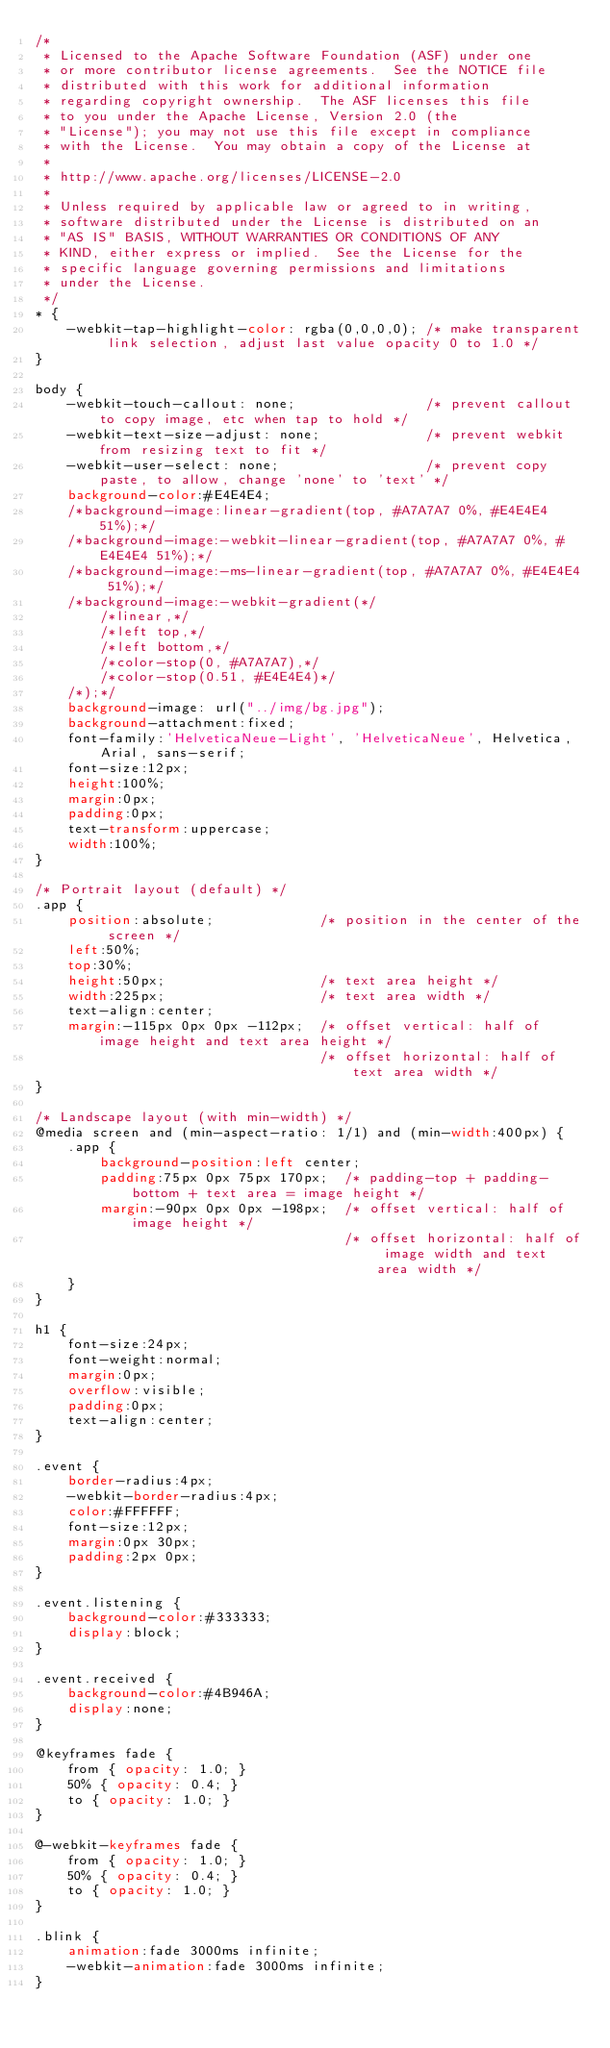Convert code to text. <code><loc_0><loc_0><loc_500><loc_500><_CSS_>/*
 * Licensed to the Apache Software Foundation (ASF) under one
 * or more contributor license agreements.  See the NOTICE file
 * distributed with this work for additional information
 * regarding copyright ownership.  The ASF licenses this file
 * to you under the Apache License, Version 2.0 (the
 * "License"); you may not use this file except in compliance
 * with the License.  You may obtain a copy of the License at
 *
 * http://www.apache.org/licenses/LICENSE-2.0
 *
 * Unless required by applicable law or agreed to in writing,
 * software distributed under the License is distributed on an
 * "AS IS" BASIS, WITHOUT WARRANTIES OR CONDITIONS OF ANY
 * KIND, either express or implied.  See the License for the
 * specific language governing permissions and limitations
 * under the License.
 */
* {
    -webkit-tap-highlight-color: rgba(0,0,0,0); /* make transparent link selection, adjust last value opacity 0 to 1.0 */
}

body {
    -webkit-touch-callout: none;                /* prevent callout to copy image, etc when tap to hold */
    -webkit-text-size-adjust: none;             /* prevent webkit from resizing text to fit */
    -webkit-user-select: none;                  /* prevent copy paste, to allow, change 'none' to 'text' */
    background-color:#E4E4E4;
    /*background-image:linear-gradient(top, #A7A7A7 0%, #E4E4E4 51%);*/
    /*background-image:-webkit-linear-gradient(top, #A7A7A7 0%, #E4E4E4 51%);*/
    /*background-image:-ms-linear-gradient(top, #A7A7A7 0%, #E4E4E4 51%);*/
    /*background-image:-webkit-gradient(*/
        /*linear,*/
        /*left top,*/
        /*left bottom,*/
        /*color-stop(0, #A7A7A7),*/
        /*color-stop(0.51, #E4E4E4)*/
    /*);*/
    background-image: url("../img/bg.jpg");
    background-attachment:fixed;
    font-family:'HelveticaNeue-Light', 'HelveticaNeue', Helvetica, Arial, sans-serif;
    font-size:12px;
    height:100%;
    margin:0px;
    padding:0px;
    text-transform:uppercase;
    width:100%;
}

/* Portrait layout (default) */
.app {
    position:absolute;             /* position in the center of the screen */
    left:50%;
    top:30%;
    height:50px;                   /* text area height */
    width:225px;                   /* text area width */
    text-align:center;
    margin:-115px 0px 0px -112px;  /* offset vertical: half of image height and text area height */
                                   /* offset horizontal: half of text area width */
}

/* Landscape layout (with min-width) */
@media screen and (min-aspect-ratio: 1/1) and (min-width:400px) {
    .app {
        background-position:left center;
        padding:75px 0px 75px 170px;  /* padding-top + padding-bottom + text area = image height */
        margin:-90px 0px 0px -198px;  /* offset vertical: half of image height */
                                      /* offset horizontal: half of image width and text area width */
    }
}

h1 {
    font-size:24px;
    font-weight:normal;
    margin:0px;
    overflow:visible;
    padding:0px;
    text-align:center;
}

.event {
    border-radius:4px;
    -webkit-border-radius:4px;
    color:#FFFFFF;
    font-size:12px;
    margin:0px 30px;
    padding:2px 0px;
}

.event.listening {
    background-color:#333333;
    display:block;
}

.event.received {
    background-color:#4B946A;
    display:none;
}

@keyframes fade {
    from { opacity: 1.0; }
    50% { opacity: 0.4; }
    to { opacity: 1.0; }
}
 
@-webkit-keyframes fade {
    from { opacity: 1.0; }
    50% { opacity: 0.4; }
    to { opacity: 1.0; }
}
 
.blink {
    animation:fade 3000ms infinite;
    -webkit-animation:fade 3000ms infinite;
}
</code> 